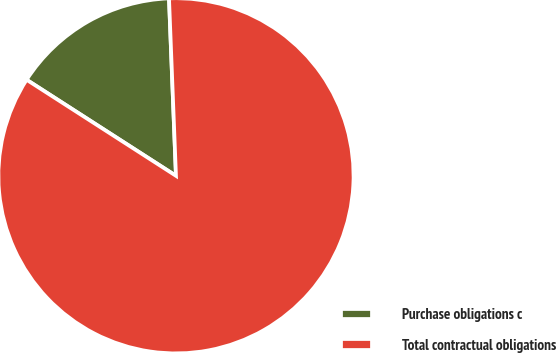Convert chart to OTSL. <chart><loc_0><loc_0><loc_500><loc_500><pie_chart><fcel>Purchase obligations c<fcel>Total contractual obligations<nl><fcel>15.28%<fcel>84.72%<nl></chart> 